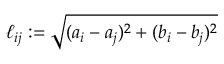Convert formula to latex. <formula><loc_0><loc_0><loc_500><loc_500>\ell _ { i j } \colon = \sqrt { ( a _ { i } - a _ { j } ) ^ { 2 } + ( b _ { i } - b _ { j } ) ^ { 2 } }</formula> 